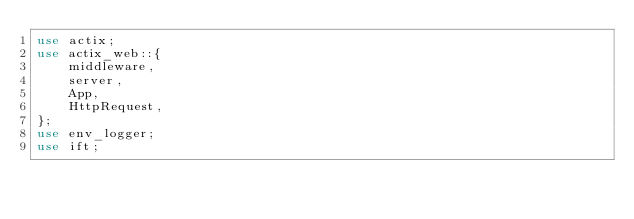<code> <loc_0><loc_0><loc_500><loc_500><_Rust_>use actix;
use actix_web::{
    middleware,
    server,
    App,
    HttpRequest,
};
use env_logger;
use ift;
</code> 